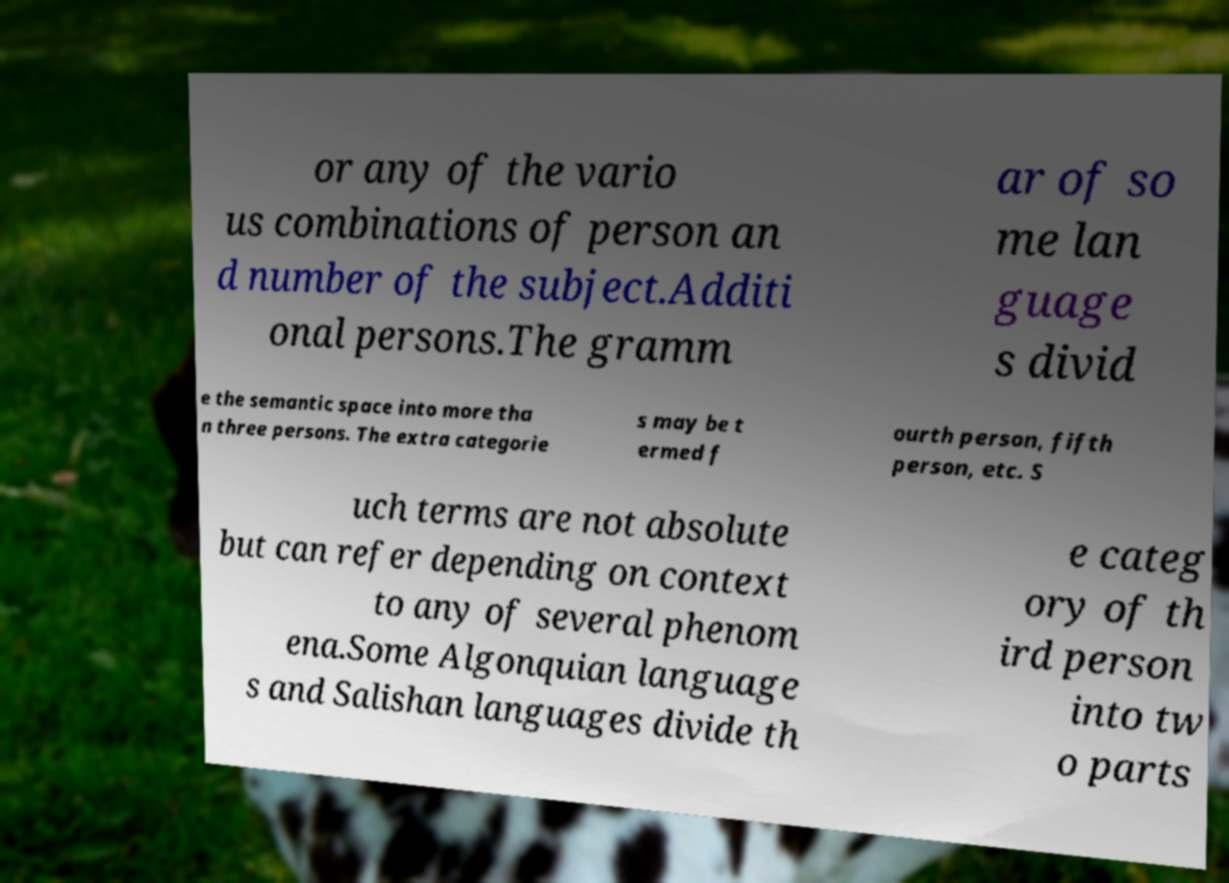For documentation purposes, I need the text within this image transcribed. Could you provide that? or any of the vario us combinations of person an d number of the subject.Additi onal persons.The gramm ar of so me lan guage s divid e the semantic space into more tha n three persons. The extra categorie s may be t ermed f ourth person, fifth person, etc. S uch terms are not absolute but can refer depending on context to any of several phenom ena.Some Algonquian language s and Salishan languages divide th e categ ory of th ird person into tw o parts 